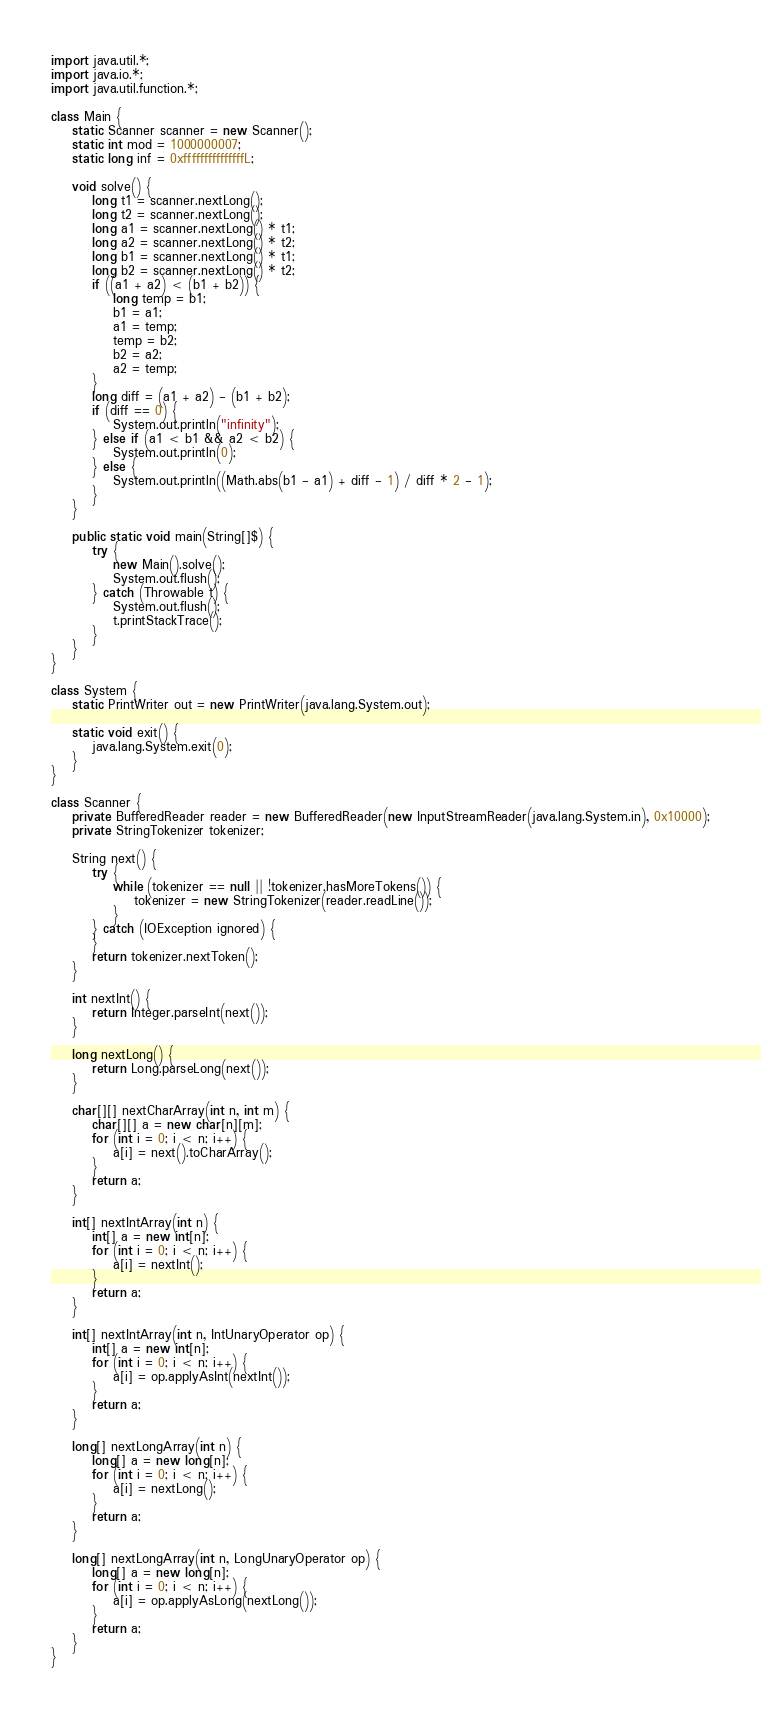<code> <loc_0><loc_0><loc_500><loc_500><_Java_>import java.util.*;
import java.io.*;
import java.util.function.*;

class Main {
    static Scanner scanner = new Scanner();
    static int mod = 1000000007;
    static long inf = 0xfffffffffffffffL;

    void solve() {
        long t1 = scanner.nextLong();
        long t2 = scanner.nextLong();
        long a1 = scanner.nextLong() * t1;
        long a2 = scanner.nextLong() * t2;
        long b1 = scanner.nextLong() * t1;
        long b2 = scanner.nextLong() * t2;
        if ((a1 + a2) < (b1 + b2)) {
            long temp = b1;
            b1 = a1;
            a1 = temp;
            temp = b2;
            b2 = a2;
            a2 = temp;
        }
        long diff = (a1 + a2) - (b1 + b2);
        if (diff == 0) {
            System.out.println("infinity");
        } else if (a1 < b1 && a2 < b2) {
            System.out.println(0);
        } else {
            System.out.println((Math.abs(b1 - a1) + diff - 1) / diff * 2 - 1);
        }
    }

    public static void main(String[]$) {
        try {
            new Main().solve();
            System.out.flush();
        } catch (Throwable t) {
            System.out.flush();
            t.printStackTrace();
        }
    }
}

class System {
    static PrintWriter out = new PrintWriter(java.lang.System.out);

    static void exit() {
        java.lang.System.exit(0);
    }
}

class Scanner {
    private BufferedReader reader = new BufferedReader(new InputStreamReader(java.lang.System.in), 0x10000);
    private StringTokenizer tokenizer;

    String next() {
        try {
            while (tokenizer == null || !tokenizer.hasMoreTokens()) {
                tokenizer = new StringTokenizer(reader.readLine());
            }
        } catch (IOException ignored) {
        }
        return tokenizer.nextToken();
    }

    int nextInt() {
        return Integer.parseInt(next());
    }

    long nextLong() {
        return Long.parseLong(next());
    }

    char[][] nextCharArray(int n, int m) {
        char[][] a = new char[n][m];
        for (int i = 0; i < n; i++) {
            a[i] = next().toCharArray();
        }
        return a;
    }

    int[] nextIntArray(int n) {
        int[] a = new int[n];
        for (int i = 0; i < n; i++) {
            a[i] = nextInt();
        }
        return a;
    }

    int[] nextIntArray(int n, IntUnaryOperator op) {
        int[] a = new int[n];
        for (int i = 0; i < n; i++) {
            a[i] = op.applyAsInt(nextInt());
        }
        return a;
    }

    long[] nextLongArray(int n) {
        long[] a = new long[n];
        for (int i = 0; i < n; i++) {
            a[i] = nextLong();
        }
        return a;
    }

    long[] nextLongArray(int n, LongUnaryOperator op) {
        long[] a = new long[n];
        for (int i = 0; i < n; i++) {
            a[i] = op.applyAsLong(nextLong());
        }
        return a;
    }
}
</code> 